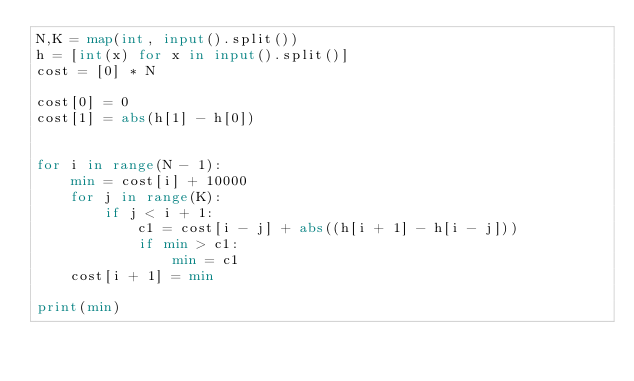Convert code to text. <code><loc_0><loc_0><loc_500><loc_500><_Python_>N,K = map(int, input().split())
h = [int(x) for x in input().split()]
cost = [0] * N

cost[0] = 0
cost[1] = abs(h[1] - h[0])


for i in range(N - 1):
    min = cost[i] + 10000
    for j in range(K):
        if j < i + 1:
            c1 = cost[i - j] + abs((h[i + 1] - h[i - j]))
            if min > c1:
                min = c1
    cost[i + 1] = min

print(min)
</code> 